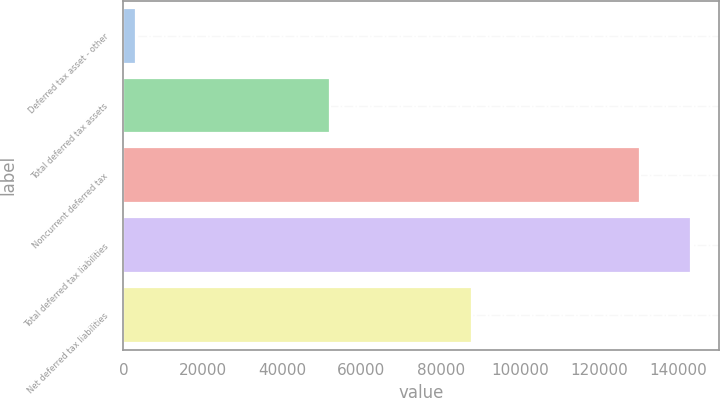Convert chart. <chart><loc_0><loc_0><loc_500><loc_500><bar_chart><fcel>Deferred tax asset - other<fcel>Total deferred tax assets<fcel>Noncurrent deferred tax<fcel>Total deferred tax liabilities<fcel>Net deferred tax liabilities<nl><fcel>3080<fcel>52039.5<fcel>130368<fcel>143102<fcel>88040<nl></chart> 